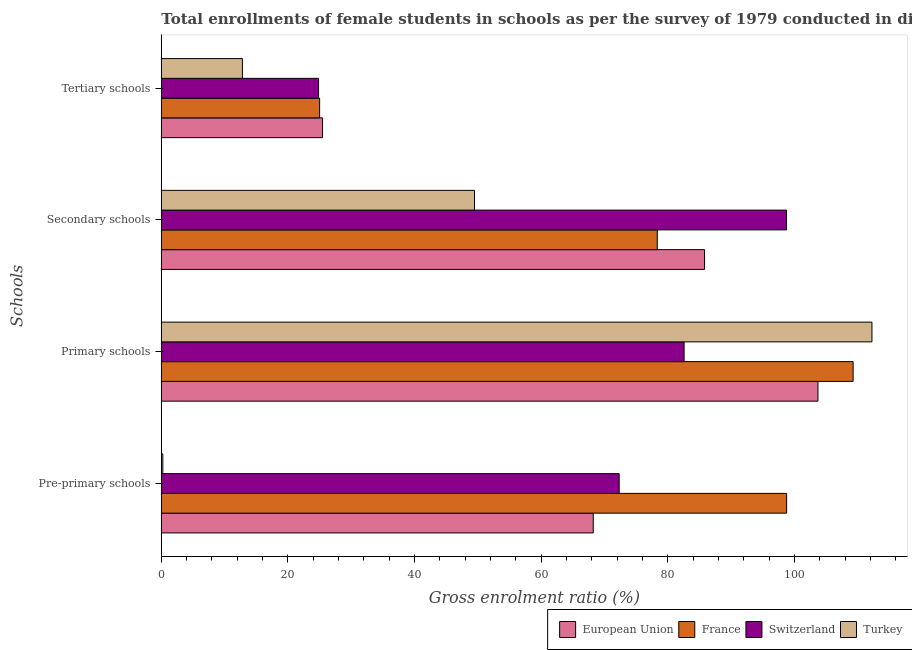How many different coloured bars are there?
Offer a very short reply. 4. How many groups of bars are there?
Make the answer very short. 4. What is the label of the 2nd group of bars from the top?
Provide a succinct answer. Secondary schools. What is the gross enrolment ratio(female) in tertiary schools in Switzerland?
Your response must be concise. 24.83. Across all countries, what is the maximum gross enrolment ratio(female) in primary schools?
Offer a terse response. 112.23. Across all countries, what is the minimum gross enrolment ratio(female) in primary schools?
Offer a very short reply. 82.56. In which country was the gross enrolment ratio(female) in primary schools maximum?
Your response must be concise. Turkey. What is the total gross enrolment ratio(female) in primary schools in the graph?
Keep it short and to the point. 407.74. What is the difference between the gross enrolment ratio(female) in tertiary schools in European Union and that in France?
Your answer should be compact. 0.46. What is the difference between the gross enrolment ratio(female) in primary schools in European Union and the gross enrolment ratio(female) in secondary schools in France?
Offer a terse response. 25.37. What is the average gross enrolment ratio(female) in secondary schools per country?
Your response must be concise. 78.08. What is the difference between the gross enrolment ratio(female) in primary schools and gross enrolment ratio(female) in pre-primary schools in France?
Ensure brevity in your answer.  10.5. In how many countries, is the gross enrolment ratio(female) in secondary schools greater than 80 %?
Make the answer very short. 2. What is the ratio of the gross enrolment ratio(female) in tertiary schools in European Union to that in Switzerland?
Ensure brevity in your answer.  1.03. Is the gross enrolment ratio(female) in primary schools in European Union less than that in Turkey?
Your answer should be very brief. Yes. Is the difference between the gross enrolment ratio(female) in secondary schools in Switzerland and European Union greater than the difference between the gross enrolment ratio(female) in primary schools in Switzerland and European Union?
Ensure brevity in your answer.  Yes. What is the difference between the highest and the second highest gross enrolment ratio(female) in tertiary schools?
Offer a very short reply. 0.46. What is the difference between the highest and the lowest gross enrolment ratio(female) in primary schools?
Offer a very short reply. 29.67. In how many countries, is the gross enrolment ratio(female) in pre-primary schools greater than the average gross enrolment ratio(female) in pre-primary schools taken over all countries?
Provide a succinct answer. 3. Is it the case that in every country, the sum of the gross enrolment ratio(female) in pre-primary schools and gross enrolment ratio(female) in secondary schools is greater than the sum of gross enrolment ratio(female) in primary schools and gross enrolment ratio(female) in tertiary schools?
Keep it short and to the point. No. What does the 2nd bar from the top in Tertiary schools represents?
Your response must be concise. Switzerland. What does the 1st bar from the bottom in Pre-primary schools represents?
Offer a very short reply. European Union. How many bars are there?
Keep it short and to the point. 16. Are the values on the major ticks of X-axis written in scientific E-notation?
Ensure brevity in your answer.  No. Does the graph contain any zero values?
Provide a succinct answer. No. Does the graph contain grids?
Make the answer very short. No. How many legend labels are there?
Offer a terse response. 4. How are the legend labels stacked?
Ensure brevity in your answer.  Horizontal. What is the title of the graph?
Offer a terse response. Total enrollments of female students in schools as per the survey of 1979 conducted in different countries. What is the label or title of the X-axis?
Your answer should be very brief. Gross enrolment ratio (%). What is the label or title of the Y-axis?
Offer a terse response. Schools. What is the Gross enrolment ratio (%) in European Union in Pre-primary schools?
Provide a short and direct response. 68.21. What is the Gross enrolment ratio (%) in France in Pre-primary schools?
Provide a short and direct response. 98.75. What is the Gross enrolment ratio (%) of Switzerland in Pre-primary schools?
Ensure brevity in your answer.  72.31. What is the Gross enrolment ratio (%) of Turkey in Pre-primary schools?
Provide a short and direct response. 0.24. What is the Gross enrolment ratio (%) in European Union in Primary schools?
Offer a terse response. 103.7. What is the Gross enrolment ratio (%) in France in Primary schools?
Give a very brief answer. 109.25. What is the Gross enrolment ratio (%) of Switzerland in Primary schools?
Ensure brevity in your answer.  82.56. What is the Gross enrolment ratio (%) in Turkey in Primary schools?
Ensure brevity in your answer.  112.23. What is the Gross enrolment ratio (%) of European Union in Secondary schools?
Provide a succinct answer. 85.79. What is the Gross enrolment ratio (%) of France in Secondary schools?
Offer a terse response. 78.33. What is the Gross enrolment ratio (%) of Switzerland in Secondary schools?
Make the answer very short. 98.73. What is the Gross enrolment ratio (%) in Turkey in Secondary schools?
Offer a terse response. 49.46. What is the Gross enrolment ratio (%) of European Union in Tertiary schools?
Provide a short and direct response. 25.46. What is the Gross enrolment ratio (%) of France in Tertiary schools?
Offer a terse response. 25. What is the Gross enrolment ratio (%) in Switzerland in Tertiary schools?
Your answer should be compact. 24.83. What is the Gross enrolment ratio (%) in Turkey in Tertiary schools?
Keep it short and to the point. 12.81. Across all Schools, what is the maximum Gross enrolment ratio (%) of European Union?
Provide a short and direct response. 103.7. Across all Schools, what is the maximum Gross enrolment ratio (%) in France?
Your answer should be very brief. 109.25. Across all Schools, what is the maximum Gross enrolment ratio (%) in Switzerland?
Give a very brief answer. 98.73. Across all Schools, what is the maximum Gross enrolment ratio (%) of Turkey?
Offer a very short reply. 112.23. Across all Schools, what is the minimum Gross enrolment ratio (%) in European Union?
Make the answer very short. 25.46. Across all Schools, what is the minimum Gross enrolment ratio (%) of France?
Keep it short and to the point. 25. Across all Schools, what is the minimum Gross enrolment ratio (%) of Switzerland?
Keep it short and to the point. 24.83. Across all Schools, what is the minimum Gross enrolment ratio (%) in Turkey?
Provide a succinct answer. 0.24. What is the total Gross enrolment ratio (%) of European Union in the graph?
Keep it short and to the point. 283.16. What is the total Gross enrolment ratio (%) in France in the graph?
Ensure brevity in your answer.  311.33. What is the total Gross enrolment ratio (%) in Switzerland in the graph?
Offer a terse response. 278.43. What is the total Gross enrolment ratio (%) in Turkey in the graph?
Make the answer very short. 174.73. What is the difference between the Gross enrolment ratio (%) in European Union in Pre-primary schools and that in Primary schools?
Provide a succinct answer. -35.49. What is the difference between the Gross enrolment ratio (%) of France in Pre-primary schools and that in Primary schools?
Provide a short and direct response. -10.5. What is the difference between the Gross enrolment ratio (%) in Switzerland in Pre-primary schools and that in Primary schools?
Offer a very short reply. -10.25. What is the difference between the Gross enrolment ratio (%) of Turkey in Pre-primary schools and that in Primary schools?
Your response must be concise. -111.99. What is the difference between the Gross enrolment ratio (%) of European Union in Pre-primary schools and that in Secondary schools?
Ensure brevity in your answer.  -17.58. What is the difference between the Gross enrolment ratio (%) of France in Pre-primary schools and that in Secondary schools?
Ensure brevity in your answer.  20.42. What is the difference between the Gross enrolment ratio (%) in Switzerland in Pre-primary schools and that in Secondary schools?
Provide a succinct answer. -26.43. What is the difference between the Gross enrolment ratio (%) in Turkey in Pre-primary schools and that in Secondary schools?
Offer a terse response. -49.22. What is the difference between the Gross enrolment ratio (%) in European Union in Pre-primary schools and that in Tertiary schools?
Make the answer very short. 42.75. What is the difference between the Gross enrolment ratio (%) of France in Pre-primary schools and that in Tertiary schools?
Offer a terse response. 73.75. What is the difference between the Gross enrolment ratio (%) in Switzerland in Pre-primary schools and that in Tertiary schools?
Offer a very short reply. 47.47. What is the difference between the Gross enrolment ratio (%) in Turkey in Pre-primary schools and that in Tertiary schools?
Offer a terse response. -12.57. What is the difference between the Gross enrolment ratio (%) in European Union in Primary schools and that in Secondary schools?
Make the answer very short. 17.91. What is the difference between the Gross enrolment ratio (%) in France in Primary schools and that in Secondary schools?
Offer a terse response. 30.93. What is the difference between the Gross enrolment ratio (%) of Switzerland in Primary schools and that in Secondary schools?
Ensure brevity in your answer.  -16.18. What is the difference between the Gross enrolment ratio (%) in Turkey in Primary schools and that in Secondary schools?
Provide a succinct answer. 62.77. What is the difference between the Gross enrolment ratio (%) in European Union in Primary schools and that in Tertiary schools?
Keep it short and to the point. 78.24. What is the difference between the Gross enrolment ratio (%) of France in Primary schools and that in Tertiary schools?
Keep it short and to the point. 84.25. What is the difference between the Gross enrolment ratio (%) of Switzerland in Primary schools and that in Tertiary schools?
Your response must be concise. 57.73. What is the difference between the Gross enrolment ratio (%) of Turkey in Primary schools and that in Tertiary schools?
Your response must be concise. 99.42. What is the difference between the Gross enrolment ratio (%) of European Union in Secondary schools and that in Tertiary schools?
Give a very brief answer. 60.33. What is the difference between the Gross enrolment ratio (%) in France in Secondary schools and that in Tertiary schools?
Ensure brevity in your answer.  53.32. What is the difference between the Gross enrolment ratio (%) of Switzerland in Secondary schools and that in Tertiary schools?
Keep it short and to the point. 73.9. What is the difference between the Gross enrolment ratio (%) in Turkey in Secondary schools and that in Tertiary schools?
Ensure brevity in your answer.  36.65. What is the difference between the Gross enrolment ratio (%) of European Union in Pre-primary schools and the Gross enrolment ratio (%) of France in Primary schools?
Ensure brevity in your answer.  -41.04. What is the difference between the Gross enrolment ratio (%) of European Union in Pre-primary schools and the Gross enrolment ratio (%) of Switzerland in Primary schools?
Offer a very short reply. -14.35. What is the difference between the Gross enrolment ratio (%) of European Union in Pre-primary schools and the Gross enrolment ratio (%) of Turkey in Primary schools?
Ensure brevity in your answer.  -44.02. What is the difference between the Gross enrolment ratio (%) in France in Pre-primary schools and the Gross enrolment ratio (%) in Switzerland in Primary schools?
Offer a very short reply. 16.19. What is the difference between the Gross enrolment ratio (%) of France in Pre-primary schools and the Gross enrolment ratio (%) of Turkey in Primary schools?
Ensure brevity in your answer.  -13.48. What is the difference between the Gross enrolment ratio (%) in Switzerland in Pre-primary schools and the Gross enrolment ratio (%) in Turkey in Primary schools?
Your response must be concise. -39.92. What is the difference between the Gross enrolment ratio (%) in European Union in Pre-primary schools and the Gross enrolment ratio (%) in France in Secondary schools?
Make the answer very short. -10.11. What is the difference between the Gross enrolment ratio (%) in European Union in Pre-primary schools and the Gross enrolment ratio (%) in Switzerland in Secondary schools?
Your answer should be compact. -30.52. What is the difference between the Gross enrolment ratio (%) of European Union in Pre-primary schools and the Gross enrolment ratio (%) of Turkey in Secondary schools?
Offer a very short reply. 18.76. What is the difference between the Gross enrolment ratio (%) in France in Pre-primary schools and the Gross enrolment ratio (%) in Switzerland in Secondary schools?
Your answer should be compact. 0.01. What is the difference between the Gross enrolment ratio (%) in France in Pre-primary schools and the Gross enrolment ratio (%) in Turkey in Secondary schools?
Offer a terse response. 49.29. What is the difference between the Gross enrolment ratio (%) in Switzerland in Pre-primary schools and the Gross enrolment ratio (%) in Turkey in Secondary schools?
Keep it short and to the point. 22.85. What is the difference between the Gross enrolment ratio (%) in European Union in Pre-primary schools and the Gross enrolment ratio (%) in France in Tertiary schools?
Make the answer very short. 43.21. What is the difference between the Gross enrolment ratio (%) in European Union in Pre-primary schools and the Gross enrolment ratio (%) in Switzerland in Tertiary schools?
Provide a succinct answer. 43.38. What is the difference between the Gross enrolment ratio (%) of European Union in Pre-primary schools and the Gross enrolment ratio (%) of Turkey in Tertiary schools?
Offer a terse response. 55.4. What is the difference between the Gross enrolment ratio (%) of France in Pre-primary schools and the Gross enrolment ratio (%) of Switzerland in Tertiary schools?
Ensure brevity in your answer.  73.91. What is the difference between the Gross enrolment ratio (%) in France in Pre-primary schools and the Gross enrolment ratio (%) in Turkey in Tertiary schools?
Ensure brevity in your answer.  85.94. What is the difference between the Gross enrolment ratio (%) of Switzerland in Pre-primary schools and the Gross enrolment ratio (%) of Turkey in Tertiary schools?
Give a very brief answer. 59.5. What is the difference between the Gross enrolment ratio (%) of European Union in Primary schools and the Gross enrolment ratio (%) of France in Secondary schools?
Provide a short and direct response. 25.37. What is the difference between the Gross enrolment ratio (%) of European Union in Primary schools and the Gross enrolment ratio (%) of Switzerland in Secondary schools?
Your answer should be compact. 4.96. What is the difference between the Gross enrolment ratio (%) in European Union in Primary schools and the Gross enrolment ratio (%) in Turkey in Secondary schools?
Give a very brief answer. 54.24. What is the difference between the Gross enrolment ratio (%) of France in Primary schools and the Gross enrolment ratio (%) of Switzerland in Secondary schools?
Give a very brief answer. 10.52. What is the difference between the Gross enrolment ratio (%) in France in Primary schools and the Gross enrolment ratio (%) in Turkey in Secondary schools?
Your response must be concise. 59.8. What is the difference between the Gross enrolment ratio (%) in Switzerland in Primary schools and the Gross enrolment ratio (%) in Turkey in Secondary schools?
Provide a short and direct response. 33.1. What is the difference between the Gross enrolment ratio (%) in European Union in Primary schools and the Gross enrolment ratio (%) in France in Tertiary schools?
Offer a terse response. 78.7. What is the difference between the Gross enrolment ratio (%) in European Union in Primary schools and the Gross enrolment ratio (%) in Switzerland in Tertiary schools?
Offer a terse response. 78.87. What is the difference between the Gross enrolment ratio (%) of European Union in Primary schools and the Gross enrolment ratio (%) of Turkey in Tertiary schools?
Your answer should be very brief. 90.89. What is the difference between the Gross enrolment ratio (%) of France in Primary schools and the Gross enrolment ratio (%) of Switzerland in Tertiary schools?
Provide a short and direct response. 84.42. What is the difference between the Gross enrolment ratio (%) in France in Primary schools and the Gross enrolment ratio (%) in Turkey in Tertiary schools?
Your response must be concise. 96.44. What is the difference between the Gross enrolment ratio (%) in Switzerland in Primary schools and the Gross enrolment ratio (%) in Turkey in Tertiary schools?
Keep it short and to the point. 69.75. What is the difference between the Gross enrolment ratio (%) of European Union in Secondary schools and the Gross enrolment ratio (%) of France in Tertiary schools?
Offer a terse response. 60.79. What is the difference between the Gross enrolment ratio (%) in European Union in Secondary schools and the Gross enrolment ratio (%) in Switzerland in Tertiary schools?
Give a very brief answer. 60.95. What is the difference between the Gross enrolment ratio (%) in European Union in Secondary schools and the Gross enrolment ratio (%) in Turkey in Tertiary schools?
Give a very brief answer. 72.98. What is the difference between the Gross enrolment ratio (%) in France in Secondary schools and the Gross enrolment ratio (%) in Switzerland in Tertiary schools?
Provide a short and direct response. 53.49. What is the difference between the Gross enrolment ratio (%) in France in Secondary schools and the Gross enrolment ratio (%) in Turkey in Tertiary schools?
Keep it short and to the point. 65.52. What is the difference between the Gross enrolment ratio (%) in Switzerland in Secondary schools and the Gross enrolment ratio (%) in Turkey in Tertiary schools?
Your response must be concise. 85.93. What is the average Gross enrolment ratio (%) of European Union per Schools?
Make the answer very short. 70.79. What is the average Gross enrolment ratio (%) of France per Schools?
Offer a very short reply. 77.83. What is the average Gross enrolment ratio (%) in Switzerland per Schools?
Keep it short and to the point. 69.61. What is the average Gross enrolment ratio (%) in Turkey per Schools?
Your answer should be compact. 43.68. What is the difference between the Gross enrolment ratio (%) in European Union and Gross enrolment ratio (%) in France in Pre-primary schools?
Offer a very short reply. -30.54. What is the difference between the Gross enrolment ratio (%) of European Union and Gross enrolment ratio (%) of Switzerland in Pre-primary schools?
Your answer should be very brief. -4.1. What is the difference between the Gross enrolment ratio (%) of European Union and Gross enrolment ratio (%) of Turkey in Pre-primary schools?
Offer a terse response. 67.97. What is the difference between the Gross enrolment ratio (%) in France and Gross enrolment ratio (%) in Switzerland in Pre-primary schools?
Provide a succinct answer. 26.44. What is the difference between the Gross enrolment ratio (%) in France and Gross enrolment ratio (%) in Turkey in Pre-primary schools?
Your answer should be compact. 98.51. What is the difference between the Gross enrolment ratio (%) in Switzerland and Gross enrolment ratio (%) in Turkey in Pre-primary schools?
Give a very brief answer. 72.07. What is the difference between the Gross enrolment ratio (%) in European Union and Gross enrolment ratio (%) in France in Primary schools?
Ensure brevity in your answer.  -5.55. What is the difference between the Gross enrolment ratio (%) of European Union and Gross enrolment ratio (%) of Switzerland in Primary schools?
Offer a very short reply. 21.14. What is the difference between the Gross enrolment ratio (%) in European Union and Gross enrolment ratio (%) in Turkey in Primary schools?
Give a very brief answer. -8.53. What is the difference between the Gross enrolment ratio (%) in France and Gross enrolment ratio (%) in Switzerland in Primary schools?
Keep it short and to the point. 26.69. What is the difference between the Gross enrolment ratio (%) in France and Gross enrolment ratio (%) in Turkey in Primary schools?
Give a very brief answer. -2.98. What is the difference between the Gross enrolment ratio (%) in Switzerland and Gross enrolment ratio (%) in Turkey in Primary schools?
Provide a short and direct response. -29.67. What is the difference between the Gross enrolment ratio (%) in European Union and Gross enrolment ratio (%) in France in Secondary schools?
Your response must be concise. 7.46. What is the difference between the Gross enrolment ratio (%) in European Union and Gross enrolment ratio (%) in Switzerland in Secondary schools?
Make the answer very short. -12.95. What is the difference between the Gross enrolment ratio (%) of European Union and Gross enrolment ratio (%) of Turkey in Secondary schools?
Your answer should be compact. 36.33. What is the difference between the Gross enrolment ratio (%) in France and Gross enrolment ratio (%) in Switzerland in Secondary schools?
Your answer should be compact. -20.41. What is the difference between the Gross enrolment ratio (%) of France and Gross enrolment ratio (%) of Turkey in Secondary schools?
Give a very brief answer. 28.87. What is the difference between the Gross enrolment ratio (%) of Switzerland and Gross enrolment ratio (%) of Turkey in Secondary schools?
Make the answer very short. 49.28. What is the difference between the Gross enrolment ratio (%) in European Union and Gross enrolment ratio (%) in France in Tertiary schools?
Provide a short and direct response. 0.46. What is the difference between the Gross enrolment ratio (%) of European Union and Gross enrolment ratio (%) of Switzerland in Tertiary schools?
Offer a very short reply. 0.63. What is the difference between the Gross enrolment ratio (%) of European Union and Gross enrolment ratio (%) of Turkey in Tertiary schools?
Provide a short and direct response. 12.65. What is the difference between the Gross enrolment ratio (%) of France and Gross enrolment ratio (%) of Switzerland in Tertiary schools?
Provide a short and direct response. 0.17. What is the difference between the Gross enrolment ratio (%) of France and Gross enrolment ratio (%) of Turkey in Tertiary schools?
Provide a succinct answer. 12.19. What is the difference between the Gross enrolment ratio (%) of Switzerland and Gross enrolment ratio (%) of Turkey in Tertiary schools?
Keep it short and to the point. 12.03. What is the ratio of the Gross enrolment ratio (%) of European Union in Pre-primary schools to that in Primary schools?
Ensure brevity in your answer.  0.66. What is the ratio of the Gross enrolment ratio (%) of France in Pre-primary schools to that in Primary schools?
Provide a short and direct response. 0.9. What is the ratio of the Gross enrolment ratio (%) in Switzerland in Pre-primary schools to that in Primary schools?
Your answer should be very brief. 0.88. What is the ratio of the Gross enrolment ratio (%) in Turkey in Pre-primary schools to that in Primary schools?
Keep it short and to the point. 0. What is the ratio of the Gross enrolment ratio (%) of European Union in Pre-primary schools to that in Secondary schools?
Make the answer very short. 0.8. What is the ratio of the Gross enrolment ratio (%) in France in Pre-primary schools to that in Secondary schools?
Provide a succinct answer. 1.26. What is the ratio of the Gross enrolment ratio (%) of Switzerland in Pre-primary schools to that in Secondary schools?
Ensure brevity in your answer.  0.73. What is the ratio of the Gross enrolment ratio (%) of Turkey in Pre-primary schools to that in Secondary schools?
Your answer should be very brief. 0. What is the ratio of the Gross enrolment ratio (%) of European Union in Pre-primary schools to that in Tertiary schools?
Your answer should be very brief. 2.68. What is the ratio of the Gross enrolment ratio (%) in France in Pre-primary schools to that in Tertiary schools?
Your answer should be very brief. 3.95. What is the ratio of the Gross enrolment ratio (%) of Switzerland in Pre-primary schools to that in Tertiary schools?
Offer a very short reply. 2.91. What is the ratio of the Gross enrolment ratio (%) in Turkey in Pre-primary schools to that in Tertiary schools?
Give a very brief answer. 0.02. What is the ratio of the Gross enrolment ratio (%) of European Union in Primary schools to that in Secondary schools?
Offer a terse response. 1.21. What is the ratio of the Gross enrolment ratio (%) in France in Primary schools to that in Secondary schools?
Offer a very short reply. 1.39. What is the ratio of the Gross enrolment ratio (%) of Switzerland in Primary schools to that in Secondary schools?
Provide a short and direct response. 0.84. What is the ratio of the Gross enrolment ratio (%) of Turkey in Primary schools to that in Secondary schools?
Provide a succinct answer. 2.27. What is the ratio of the Gross enrolment ratio (%) of European Union in Primary schools to that in Tertiary schools?
Offer a very short reply. 4.07. What is the ratio of the Gross enrolment ratio (%) of France in Primary schools to that in Tertiary schools?
Your response must be concise. 4.37. What is the ratio of the Gross enrolment ratio (%) in Switzerland in Primary schools to that in Tertiary schools?
Your response must be concise. 3.32. What is the ratio of the Gross enrolment ratio (%) in Turkey in Primary schools to that in Tertiary schools?
Offer a terse response. 8.76. What is the ratio of the Gross enrolment ratio (%) of European Union in Secondary schools to that in Tertiary schools?
Provide a succinct answer. 3.37. What is the ratio of the Gross enrolment ratio (%) in France in Secondary schools to that in Tertiary schools?
Offer a terse response. 3.13. What is the ratio of the Gross enrolment ratio (%) in Switzerland in Secondary schools to that in Tertiary schools?
Offer a very short reply. 3.98. What is the ratio of the Gross enrolment ratio (%) in Turkey in Secondary schools to that in Tertiary schools?
Give a very brief answer. 3.86. What is the difference between the highest and the second highest Gross enrolment ratio (%) of European Union?
Provide a short and direct response. 17.91. What is the difference between the highest and the second highest Gross enrolment ratio (%) of France?
Your response must be concise. 10.5. What is the difference between the highest and the second highest Gross enrolment ratio (%) in Switzerland?
Your answer should be very brief. 16.18. What is the difference between the highest and the second highest Gross enrolment ratio (%) in Turkey?
Offer a very short reply. 62.77. What is the difference between the highest and the lowest Gross enrolment ratio (%) in European Union?
Your answer should be compact. 78.24. What is the difference between the highest and the lowest Gross enrolment ratio (%) of France?
Ensure brevity in your answer.  84.25. What is the difference between the highest and the lowest Gross enrolment ratio (%) in Switzerland?
Provide a short and direct response. 73.9. What is the difference between the highest and the lowest Gross enrolment ratio (%) of Turkey?
Your answer should be compact. 111.99. 